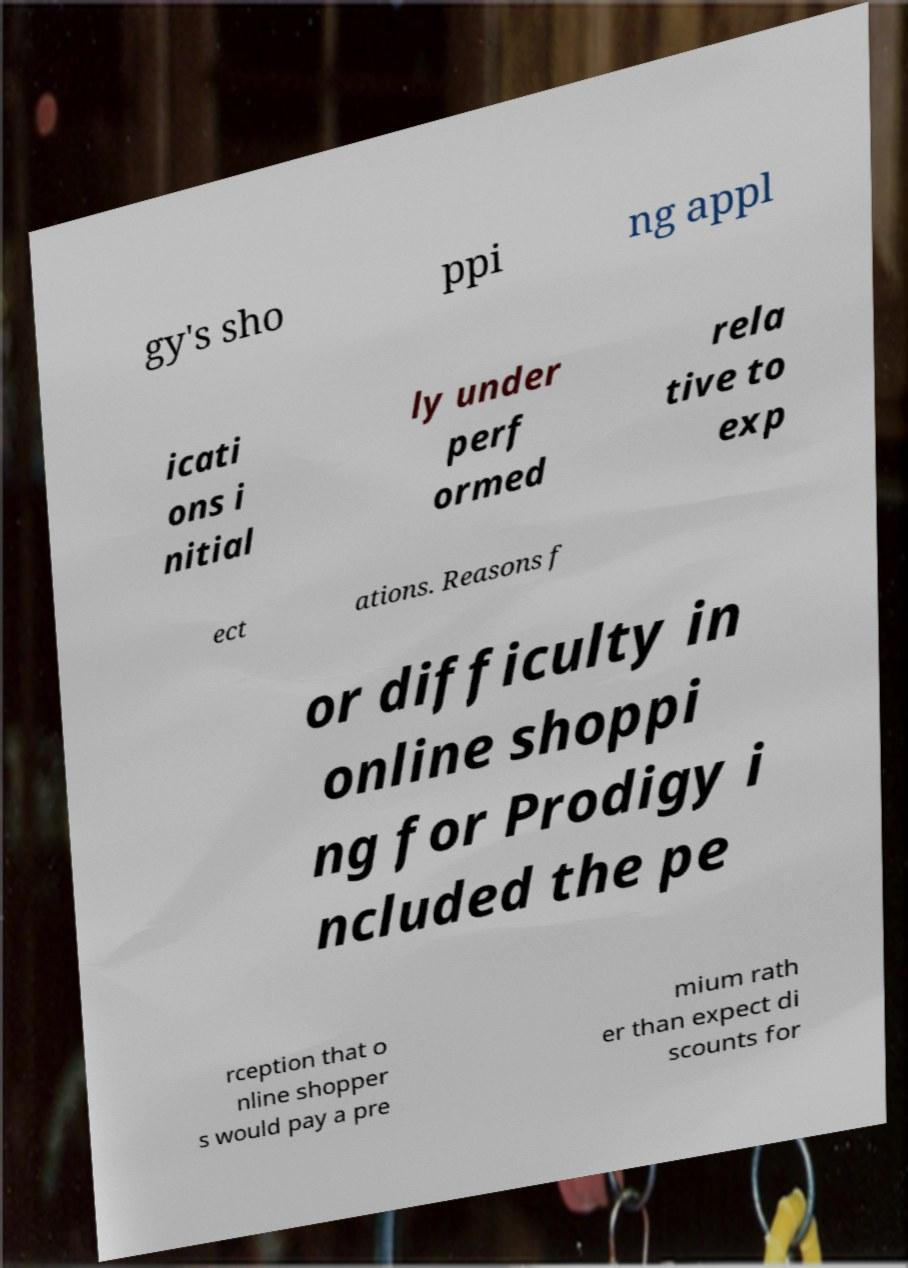Can you read and provide the text displayed in the image?This photo seems to have some interesting text. Can you extract and type it out for me? gy's sho ppi ng appl icati ons i nitial ly under perf ormed rela tive to exp ect ations. Reasons f or difficulty in online shoppi ng for Prodigy i ncluded the pe rception that o nline shopper s would pay a pre mium rath er than expect di scounts for 